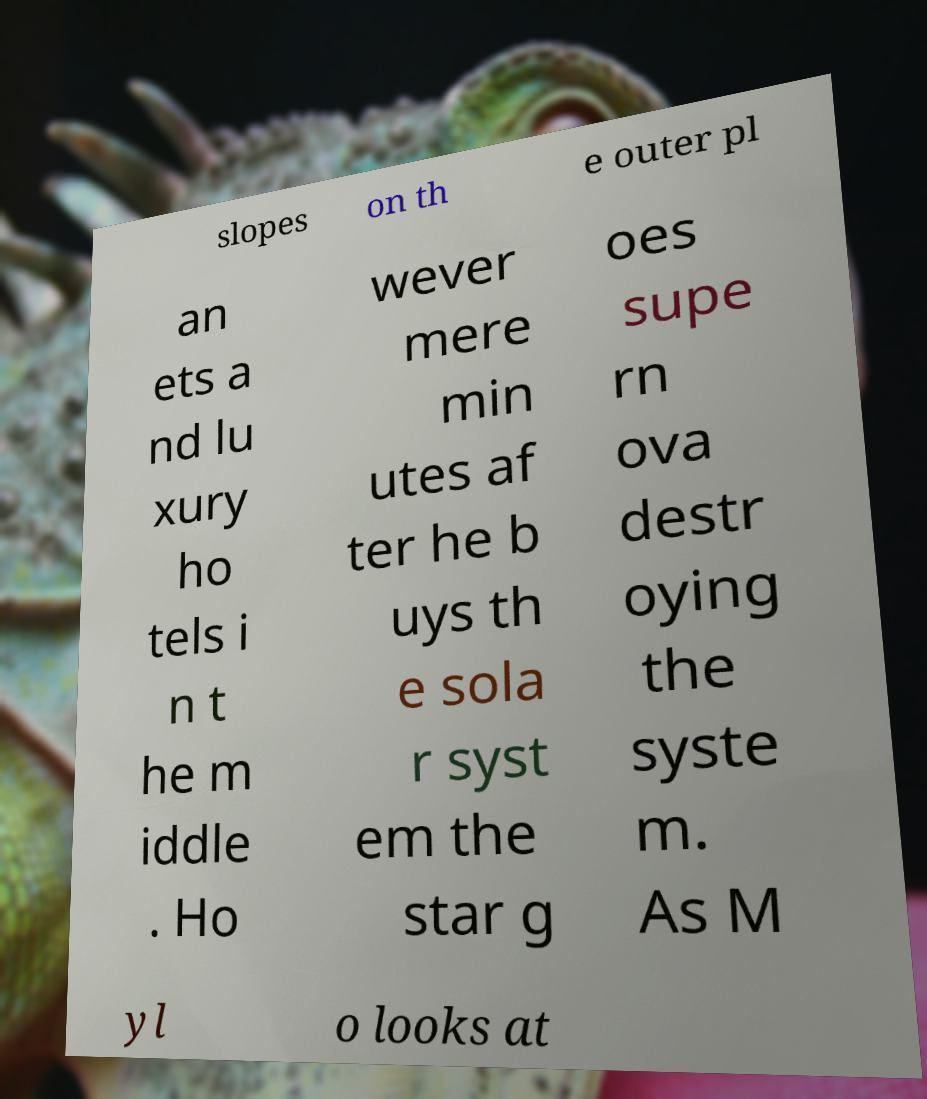For documentation purposes, I need the text within this image transcribed. Could you provide that? slopes on th e outer pl an ets a nd lu xury ho tels i n t he m iddle . Ho wever mere min utes af ter he b uys th e sola r syst em the star g oes supe rn ova destr oying the syste m. As M yl o looks at 